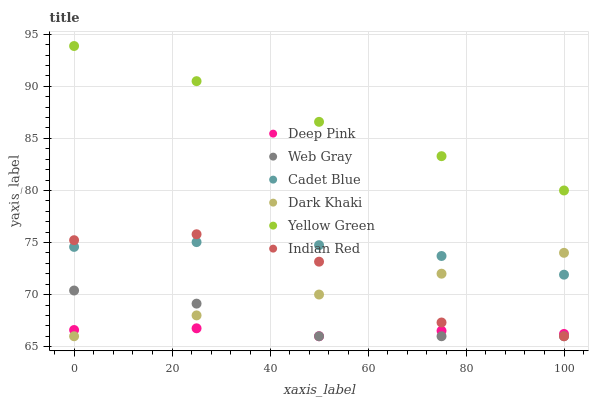Does Deep Pink have the minimum area under the curve?
Answer yes or no. Yes. Does Yellow Green have the maximum area under the curve?
Answer yes or no. Yes. Does Dark Khaki have the minimum area under the curve?
Answer yes or no. No. Does Dark Khaki have the maximum area under the curve?
Answer yes or no. No. Is Dark Khaki the smoothest?
Answer yes or no. Yes. Is Indian Red the roughest?
Answer yes or no. Yes. Is Yellow Green the smoothest?
Answer yes or no. No. Is Yellow Green the roughest?
Answer yes or no. No. Does Dark Khaki have the lowest value?
Answer yes or no. Yes. Does Yellow Green have the lowest value?
Answer yes or no. No. Does Yellow Green have the highest value?
Answer yes or no. Yes. Does Dark Khaki have the highest value?
Answer yes or no. No. Is Deep Pink less than Cadet Blue?
Answer yes or no. Yes. Is Yellow Green greater than Dark Khaki?
Answer yes or no. Yes. Does Web Gray intersect Dark Khaki?
Answer yes or no. Yes. Is Web Gray less than Dark Khaki?
Answer yes or no. No. Is Web Gray greater than Dark Khaki?
Answer yes or no. No. Does Deep Pink intersect Cadet Blue?
Answer yes or no. No. 